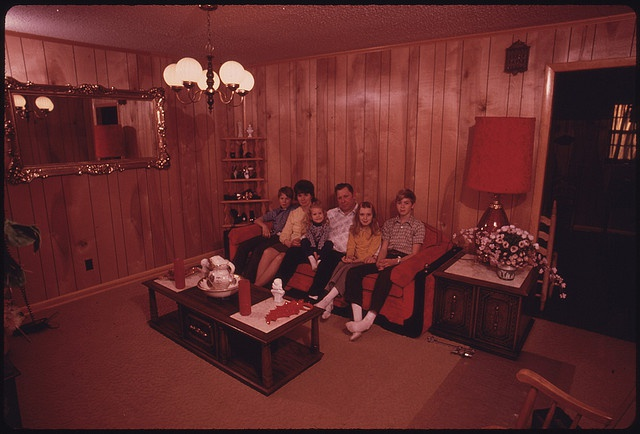Describe the objects in this image and their specific colors. I can see couch in black, maroon, and brown tones, people in black, maroon, and brown tones, chair in black, maroon, and brown tones, potted plant in black, maroon, and brown tones, and people in black, maroon, and brown tones in this image. 